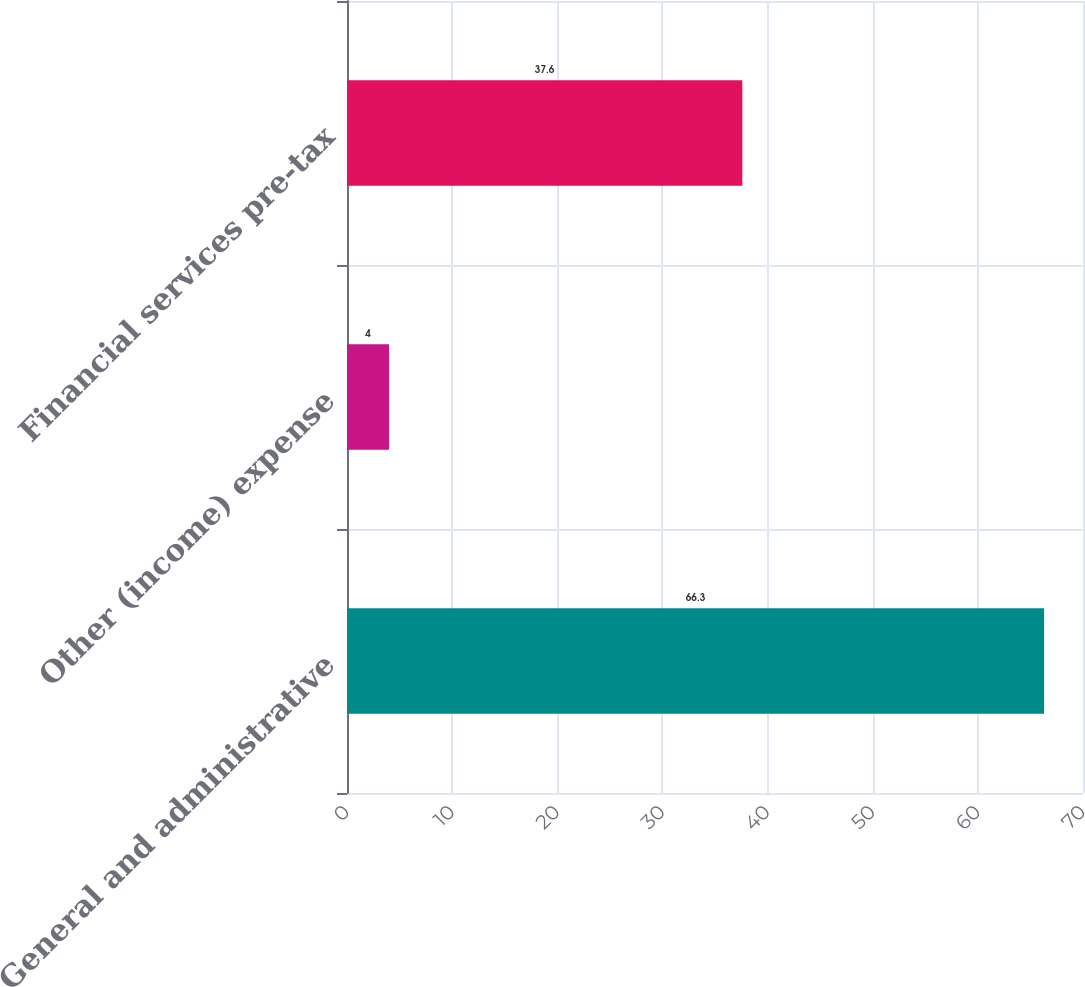Convert chart. <chart><loc_0><loc_0><loc_500><loc_500><bar_chart><fcel>General and administrative<fcel>Other (income) expense<fcel>Financial services pre-tax<nl><fcel>66.3<fcel>4<fcel>37.6<nl></chart> 